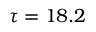<formula> <loc_0><loc_0><loc_500><loc_500>\tau = 1 8 . 2</formula> 